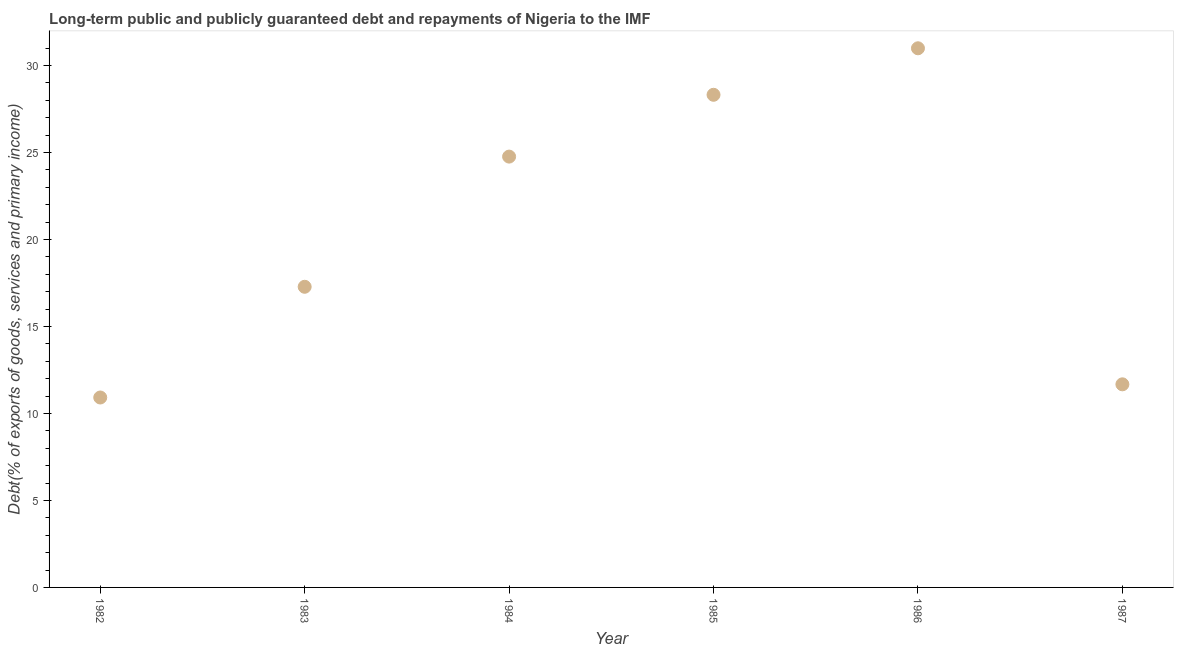What is the debt service in 1985?
Give a very brief answer. 28.32. Across all years, what is the maximum debt service?
Offer a very short reply. 30.99. Across all years, what is the minimum debt service?
Ensure brevity in your answer.  10.92. In which year was the debt service maximum?
Offer a terse response. 1986. What is the sum of the debt service?
Your answer should be very brief. 123.94. What is the difference between the debt service in 1983 and 1987?
Keep it short and to the point. 5.61. What is the average debt service per year?
Your answer should be very brief. 20.66. What is the median debt service?
Make the answer very short. 21.02. What is the ratio of the debt service in 1983 to that in 1986?
Your response must be concise. 0.56. Is the debt service in 1982 less than that in 1987?
Make the answer very short. Yes. What is the difference between the highest and the second highest debt service?
Ensure brevity in your answer.  2.67. What is the difference between the highest and the lowest debt service?
Provide a short and direct response. 20.07. Does the graph contain any zero values?
Offer a terse response. No. What is the title of the graph?
Make the answer very short. Long-term public and publicly guaranteed debt and repayments of Nigeria to the IMF. What is the label or title of the X-axis?
Provide a succinct answer. Year. What is the label or title of the Y-axis?
Ensure brevity in your answer.  Debt(% of exports of goods, services and primary income). What is the Debt(% of exports of goods, services and primary income) in 1982?
Your response must be concise. 10.92. What is the Debt(% of exports of goods, services and primary income) in 1983?
Your answer should be very brief. 17.28. What is the Debt(% of exports of goods, services and primary income) in 1984?
Make the answer very short. 24.76. What is the Debt(% of exports of goods, services and primary income) in 1985?
Your answer should be very brief. 28.32. What is the Debt(% of exports of goods, services and primary income) in 1986?
Offer a terse response. 30.99. What is the Debt(% of exports of goods, services and primary income) in 1987?
Your answer should be compact. 11.67. What is the difference between the Debt(% of exports of goods, services and primary income) in 1982 and 1983?
Your answer should be compact. -6.36. What is the difference between the Debt(% of exports of goods, services and primary income) in 1982 and 1984?
Keep it short and to the point. -13.85. What is the difference between the Debt(% of exports of goods, services and primary income) in 1982 and 1985?
Your response must be concise. -17.4. What is the difference between the Debt(% of exports of goods, services and primary income) in 1982 and 1986?
Make the answer very short. -20.07. What is the difference between the Debt(% of exports of goods, services and primary income) in 1982 and 1987?
Ensure brevity in your answer.  -0.76. What is the difference between the Debt(% of exports of goods, services and primary income) in 1983 and 1984?
Make the answer very short. -7.48. What is the difference between the Debt(% of exports of goods, services and primary income) in 1983 and 1985?
Provide a short and direct response. -11.04. What is the difference between the Debt(% of exports of goods, services and primary income) in 1983 and 1986?
Provide a succinct answer. -13.71. What is the difference between the Debt(% of exports of goods, services and primary income) in 1983 and 1987?
Provide a short and direct response. 5.61. What is the difference between the Debt(% of exports of goods, services and primary income) in 1984 and 1985?
Your response must be concise. -3.55. What is the difference between the Debt(% of exports of goods, services and primary income) in 1984 and 1986?
Your answer should be very brief. -6.23. What is the difference between the Debt(% of exports of goods, services and primary income) in 1984 and 1987?
Provide a succinct answer. 13.09. What is the difference between the Debt(% of exports of goods, services and primary income) in 1985 and 1986?
Ensure brevity in your answer.  -2.67. What is the difference between the Debt(% of exports of goods, services and primary income) in 1985 and 1987?
Ensure brevity in your answer.  16.64. What is the difference between the Debt(% of exports of goods, services and primary income) in 1986 and 1987?
Keep it short and to the point. 19.32. What is the ratio of the Debt(% of exports of goods, services and primary income) in 1982 to that in 1983?
Make the answer very short. 0.63. What is the ratio of the Debt(% of exports of goods, services and primary income) in 1982 to that in 1984?
Make the answer very short. 0.44. What is the ratio of the Debt(% of exports of goods, services and primary income) in 1982 to that in 1985?
Keep it short and to the point. 0.39. What is the ratio of the Debt(% of exports of goods, services and primary income) in 1982 to that in 1986?
Give a very brief answer. 0.35. What is the ratio of the Debt(% of exports of goods, services and primary income) in 1982 to that in 1987?
Offer a very short reply. 0.94. What is the ratio of the Debt(% of exports of goods, services and primary income) in 1983 to that in 1984?
Provide a short and direct response. 0.7. What is the ratio of the Debt(% of exports of goods, services and primary income) in 1983 to that in 1985?
Offer a terse response. 0.61. What is the ratio of the Debt(% of exports of goods, services and primary income) in 1983 to that in 1986?
Ensure brevity in your answer.  0.56. What is the ratio of the Debt(% of exports of goods, services and primary income) in 1983 to that in 1987?
Keep it short and to the point. 1.48. What is the ratio of the Debt(% of exports of goods, services and primary income) in 1984 to that in 1986?
Ensure brevity in your answer.  0.8. What is the ratio of the Debt(% of exports of goods, services and primary income) in 1984 to that in 1987?
Provide a succinct answer. 2.12. What is the ratio of the Debt(% of exports of goods, services and primary income) in 1985 to that in 1986?
Give a very brief answer. 0.91. What is the ratio of the Debt(% of exports of goods, services and primary income) in 1985 to that in 1987?
Offer a very short reply. 2.43. What is the ratio of the Debt(% of exports of goods, services and primary income) in 1986 to that in 1987?
Make the answer very short. 2.65. 